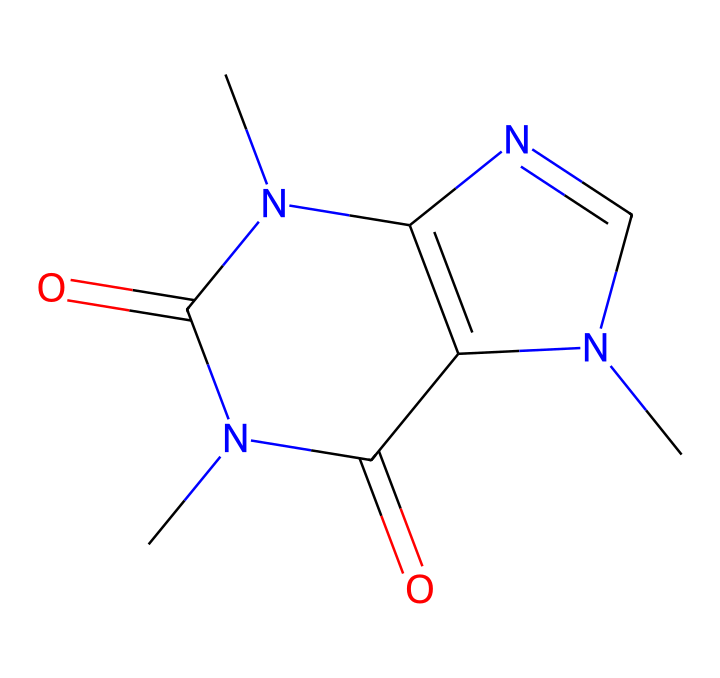What is the molecular formula of caffeine? To determine the molecular formula, we analyze the SMILES representation: CN1C=NC2=C1C(=O)N(C(=O)N2C)C. Counting each type of atom, we find 8 carbon (C) atoms, 10 hydrogen (H) atoms, 4 nitrogen (N) atoms, and 2 oxygen (O) atoms. Thus, the molecular formula is C8H10N4O2.
Answer: C8H10N4O2 How many nitrogen atoms are in caffeine? By inspecting the SMILES structure, we can see that there are four nitrogen atoms present in the compound. Each nitrogen can be counted directly from the representation.
Answer: four What basic functionality does caffeine exhibit? Examining the molecule, caffeine contains nitrogen atoms arranged in a structure typical for alkaloids, which often have stimulant properties. The presence of nitrogen and cyclic structure indicates it functions as a stimulant.
Answer: stimulant Does caffeine contain any functional groups? The chemical structure reveals the presence of carbonyl groups (C=O) associated with nitrogen atoms, which point to the presence of amide functional groups. This indicates that caffeine contains functional groups.
Answer: yes What is the main pharmacological effect of caffeine? Based on the structure and known characteristics of caffeine, it primarily acts as a central nervous system stimulant, which generally results in increased alertness and reduced fatigue.
Answer: stimulant What type of compound is caffeine classified as? Caffeine is classified as an alkaloid due to its basic nitrogen structure and its origin from a plant source, which is typical for many alkaloids.
Answer: alkaloid 